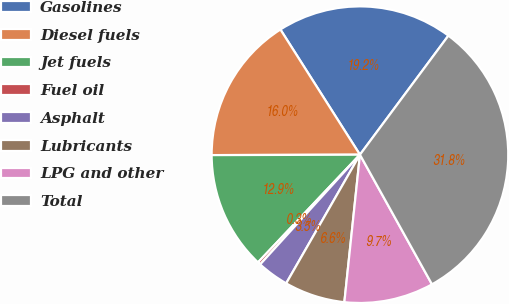Convert chart to OTSL. <chart><loc_0><loc_0><loc_500><loc_500><pie_chart><fcel>Gasolines<fcel>Diesel fuels<fcel>Jet fuels<fcel>Fuel oil<fcel>Asphalt<fcel>Lubricants<fcel>LPG and other<fcel>Total<nl><fcel>19.18%<fcel>16.04%<fcel>12.89%<fcel>0.32%<fcel>3.46%<fcel>6.61%<fcel>9.75%<fcel>31.76%<nl></chart> 